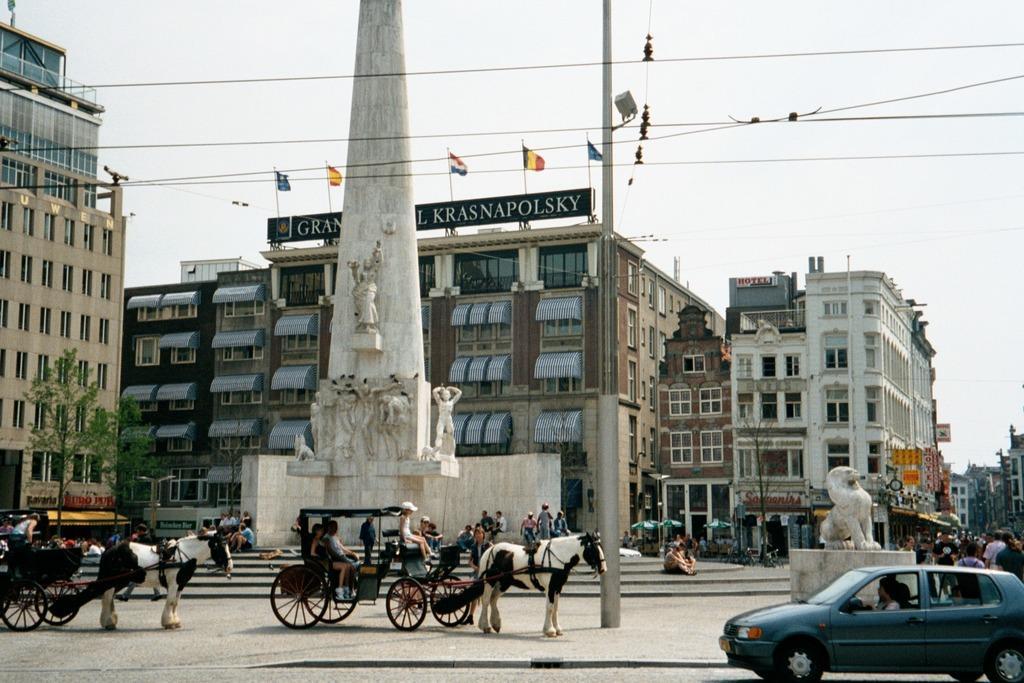Describe this image in one or two sentences. In this image there are group of people some are standing and some are sitting in the car,there is a horse and a car on the road. There is a statue in the middle of the road. At the background there is a building,tree, sky. and there is a flag on the building. 